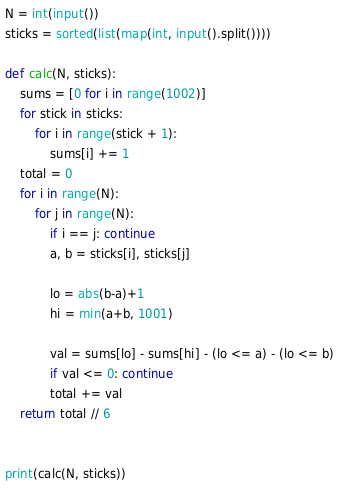<code> <loc_0><loc_0><loc_500><loc_500><_Python_>N = int(input())
sticks = sorted(list(map(int, input().split())))

def calc(N, sticks):
    sums = [0 for i in range(1002)]
    for stick in sticks:
        for i in range(stick + 1):
            sums[i] += 1
    total = 0
    for i in range(N):
        for j in range(N):
            if i == j: continue
            a, b = sticks[i], sticks[j]

            lo = abs(b-a)+1
            hi = min(a+b, 1001)
            
            val = sums[lo] - sums[hi] - (lo <= a) - (lo <= b)
            if val <= 0: continue
            total += val
    return total // 6


print(calc(N, sticks))
</code> 